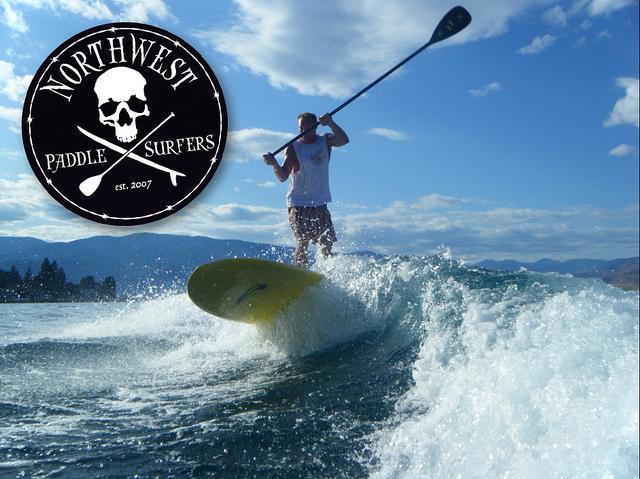How many boat on the seasore?
Give a very brief answer. 0. 